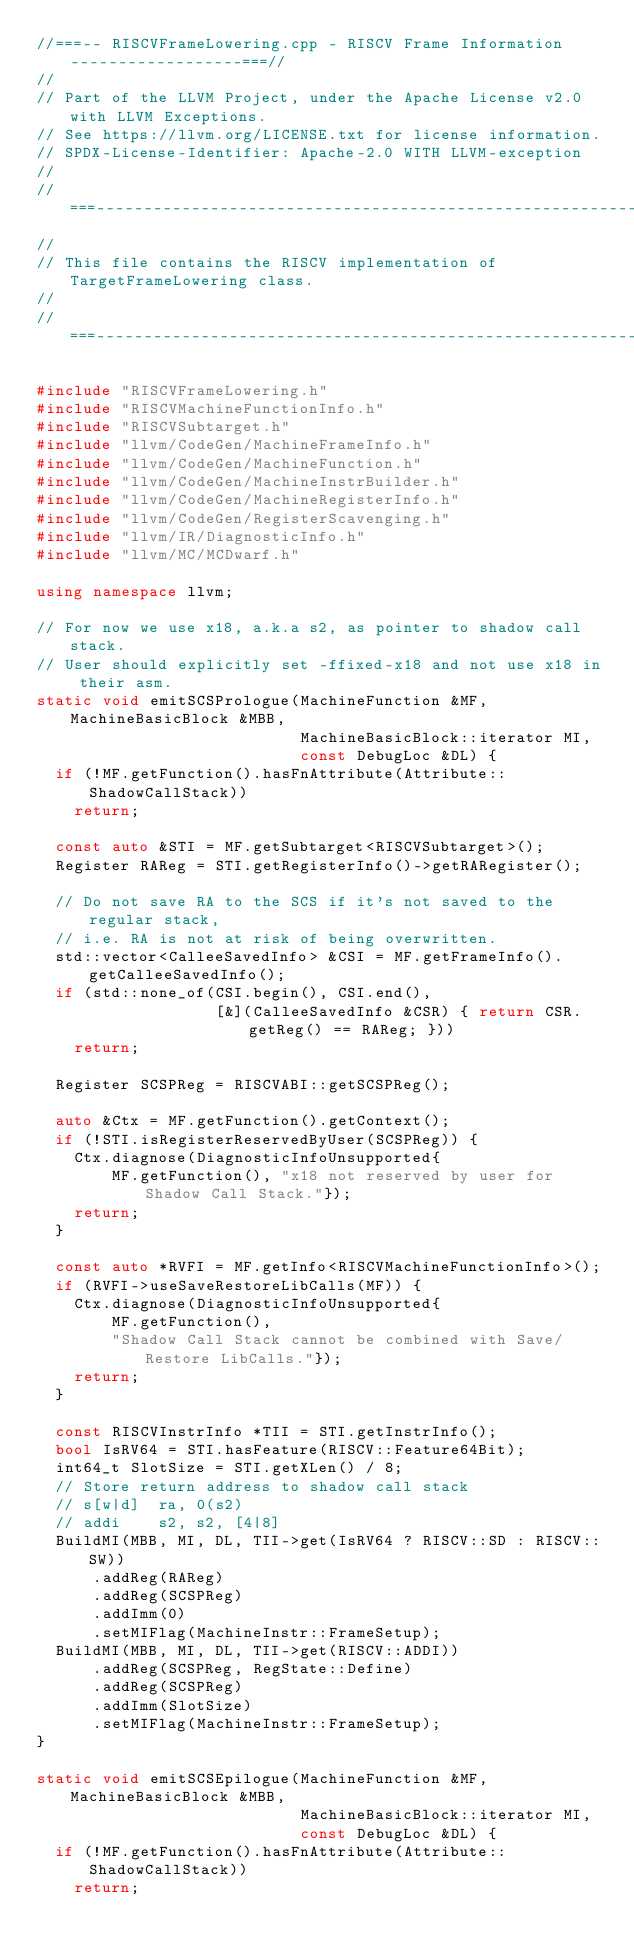<code> <loc_0><loc_0><loc_500><loc_500><_C++_>//===-- RISCVFrameLowering.cpp - RISCV Frame Information ------------------===//
//
// Part of the LLVM Project, under the Apache License v2.0 with LLVM Exceptions.
// See https://llvm.org/LICENSE.txt for license information.
// SPDX-License-Identifier: Apache-2.0 WITH LLVM-exception
//
//===----------------------------------------------------------------------===//
//
// This file contains the RISCV implementation of TargetFrameLowering class.
//
//===----------------------------------------------------------------------===//

#include "RISCVFrameLowering.h"
#include "RISCVMachineFunctionInfo.h"
#include "RISCVSubtarget.h"
#include "llvm/CodeGen/MachineFrameInfo.h"
#include "llvm/CodeGen/MachineFunction.h"
#include "llvm/CodeGen/MachineInstrBuilder.h"
#include "llvm/CodeGen/MachineRegisterInfo.h"
#include "llvm/CodeGen/RegisterScavenging.h"
#include "llvm/IR/DiagnosticInfo.h"
#include "llvm/MC/MCDwarf.h"

using namespace llvm;

// For now we use x18, a.k.a s2, as pointer to shadow call stack.
// User should explicitly set -ffixed-x18 and not use x18 in their asm.
static void emitSCSPrologue(MachineFunction &MF, MachineBasicBlock &MBB,
                            MachineBasicBlock::iterator MI,
                            const DebugLoc &DL) {
  if (!MF.getFunction().hasFnAttribute(Attribute::ShadowCallStack))
    return;

  const auto &STI = MF.getSubtarget<RISCVSubtarget>();
  Register RAReg = STI.getRegisterInfo()->getRARegister();

  // Do not save RA to the SCS if it's not saved to the regular stack,
  // i.e. RA is not at risk of being overwritten.
  std::vector<CalleeSavedInfo> &CSI = MF.getFrameInfo().getCalleeSavedInfo();
  if (std::none_of(CSI.begin(), CSI.end(),
                   [&](CalleeSavedInfo &CSR) { return CSR.getReg() == RAReg; }))
    return;

  Register SCSPReg = RISCVABI::getSCSPReg();

  auto &Ctx = MF.getFunction().getContext();
  if (!STI.isRegisterReservedByUser(SCSPReg)) {
    Ctx.diagnose(DiagnosticInfoUnsupported{
        MF.getFunction(), "x18 not reserved by user for Shadow Call Stack."});
    return;
  }

  const auto *RVFI = MF.getInfo<RISCVMachineFunctionInfo>();
  if (RVFI->useSaveRestoreLibCalls(MF)) {
    Ctx.diagnose(DiagnosticInfoUnsupported{
        MF.getFunction(),
        "Shadow Call Stack cannot be combined with Save/Restore LibCalls."});
    return;
  }

  const RISCVInstrInfo *TII = STI.getInstrInfo();
  bool IsRV64 = STI.hasFeature(RISCV::Feature64Bit);
  int64_t SlotSize = STI.getXLen() / 8;
  // Store return address to shadow call stack
  // s[w|d]  ra, 0(s2)
  // addi    s2, s2, [4|8]
  BuildMI(MBB, MI, DL, TII->get(IsRV64 ? RISCV::SD : RISCV::SW))
      .addReg(RAReg)
      .addReg(SCSPReg)
      .addImm(0)
      .setMIFlag(MachineInstr::FrameSetup);
  BuildMI(MBB, MI, DL, TII->get(RISCV::ADDI))
      .addReg(SCSPReg, RegState::Define)
      .addReg(SCSPReg)
      .addImm(SlotSize)
      .setMIFlag(MachineInstr::FrameSetup);
}

static void emitSCSEpilogue(MachineFunction &MF, MachineBasicBlock &MBB,
                            MachineBasicBlock::iterator MI,
                            const DebugLoc &DL) {
  if (!MF.getFunction().hasFnAttribute(Attribute::ShadowCallStack))
    return;
</code> 